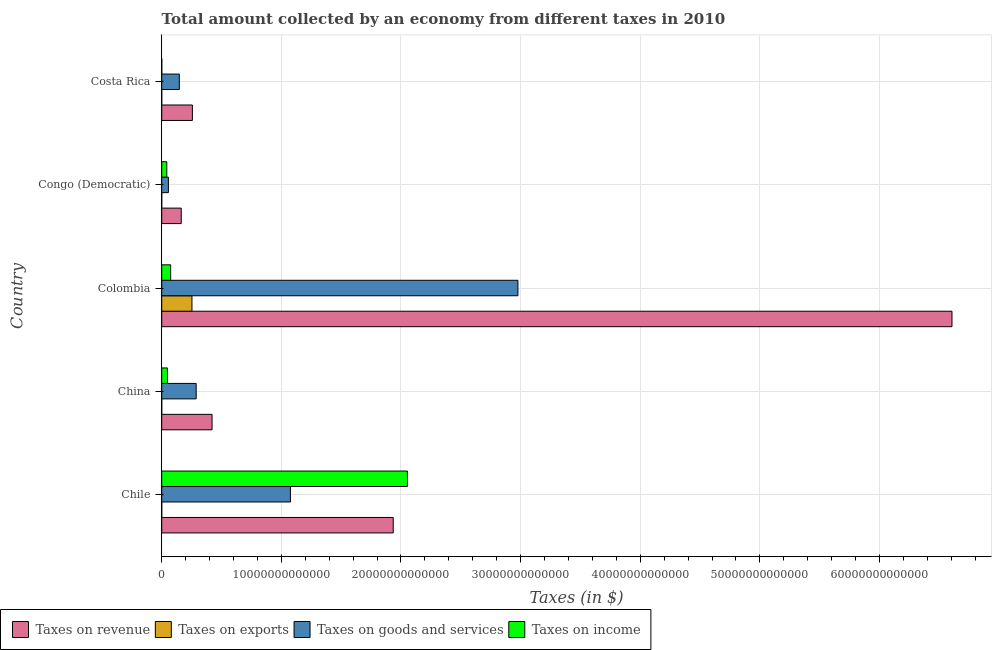How many different coloured bars are there?
Provide a short and direct response. 4. How many groups of bars are there?
Your answer should be very brief. 5. Are the number of bars per tick equal to the number of legend labels?
Ensure brevity in your answer.  Yes. How many bars are there on the 3rd tick from the bottom?
Your answer should be very brief. 4. What is the label of the 2nd group of bars from the top?
Your answer should be very brief. Congo (Democratic). In how many cases, is the number of bars for a given country not equal to the number of legend labels?
Your answer should be compact. 0. What is the amount collected as tax on exports in Congo (Democratic)?
Make the answer very short. 5.69e+06. Across all countries, what is the maximum amount collected as tax on revenue?
Give a very brief answer. 6.61e+13. Across all countries, what is the minimum amount collected as tax on exports?
Make the answer very short. 5.69e+06. In which country was the amount collected as tax on income maximum?
Your answer should be compact. Chile. In which country was the amount collected as tax on revenue minimum?
Ensure brevity in your answer.  Congo (Democratic). What is the total amount collected as tax on revenue in the graph?
Your response must be concise. 9.38e+13. What is the difference between the amount collected as tax on exports in Colombia and that in Congo (Democratic)?
Provide a short and direct response. 2.53e+12. What is the difference between the amount collected as tax on income in Colombia and the amount collected as tax on exports in Congo (Democratic)?
Provide a succinct answer. 7.48e+11. What is the average amount collected as tax on income per country?
Provide a succinct answer. 4.44e+12. What is the difference between the amount collected as tax on revenue and amount collected as tax on exports in Chile?
Give a very brief answer. 1.94e+13. In how many countries, is the amount collected as tax on income greater than 12000000000000 $?
Your response must be concise. 1. What is the ratio of the amount collected as tax on income in Chile to that in China?
Offer a terse response. 42.85. What is the difference between the highest and the second highest amount collected as tax on goods?
Offer a very short reply. 1.90e+13. What is the difference between the highest and the lowest amount collected as tax on income?
Make the answer very short. 2.05e+13. Is the sum of the amount collected as tax on exports in Chile and Colombia greater than the maximum amount collected as tax on goods across all countries?
Offer a very short reply. No. Is it the case that in every country, the sum of the amount collected as tax on income and amount collected as tax on revenue is greater than the sum of amount collected as tax on goods and amount collected as tax on exports?
Offer a very short reply. No. What does the 2nd bar from the top in Congo (Democratic) represents?
Provide a succinct answer. Taxes on goods and services. What does the 3rd bar from the bottom in Congo (Democratic) represents?
Your answer should be very brief. Taxes on goods and services. How many bars are there?
Ensure brevity in your answer.  20. How many countries are there in the graph?
Your answer should be very brief. 5. What is the difference between two consecutive major ticks on the X-axis?
Your answer should be very brief. 1.00e+13. Does the graph contain any zero values?
Give a very brief answer. No. Where does the legend appear in the graph?
Provide a succinct answer. Bottom left. What is the title of the graph?
Ensure brevity in your answer.  Total amount collected by an economy from different taxes in 2010. What is the label or title of the X-axis?
Give a very brief answer. Taxes (in $). What is the Taxes (in $) of Taxes on revenue in Chile?
Ensure brevity in your answer.  1.94e+13. What is the Taxes (in $) of Taxes on exports in Chile?
Your response must be concise. 9.15e+08. What is the Taxes (in $) in Taxes on goods and services in Chile?
Ensure brevity in your answer.  1.08e+13. What is the Taxes (in $) in Taxes on income in Chile?
Your answer should be compact. 2.05e+13. What is the Taxes (in $) of Taxes on revenue in China?
Make the answer very short. 4.21e+12. What is the Taxes (in $) in Taxes on exports in China?
Ensure brevity in your answer.  1.50e+08. What is the Taxes (in $) in Taxes on goods and services in China?
Keep it short and to the point. 2.88e+12. What is the Taxes (in $) in Taxes on income in China?
Your answer should be very brief. 4.79e+11. What is the Taxes (in $) in Taxes on revenue in Colombia?
Offer a very short reply. 6.61e+13. What is the Taxes (in $) of Taxes on exports in Colombia?
Ensure brevity in your answer.  2.53e+12. What is the Taxes (in $) in Taxes on goods and services in Colombia?
Your answer should be very brief. 2.98e+13. What is the Taxes (in $) in Taxes on income in Colombia?
Offer a terse response. 7.48e+11. What is the Taxes (in $) of Taxes on revenue in Congo (Democratic)?
Give a very brief answer. 1.63e+12. What is the Taxes (in $) in Taxes on exports in Congo (Democratic)?
Provide a succinct answer. 5.69e+06. What is the Taxes (in $) in Taxes on goods and services in Congo (Democratic)?
Ensure brevity in your answer.  5.59e+11. What is the Taxes (in $) in Taxes on income in Congo (Democratic)?
Your response must be concise. 4.24e+11. What is the Taxes (in $) of Taxes on revenue in Costa Rica?
Make the answer very short. 2.56e+12. What is the Taxes (in $) in Taxes on exports in Costa Rica?
Your answer should be very brief. 7.04e+07. What is the Taxes (in $) in Taxes on goods and services in Costa Rica?
Your answer should be compact. 1.47e+12. What is the Taxes (in $) in Taxes on income in Costa Rica?
Your response must be concise. 7.61e+09. Across all countries, what is the maximum Taxes (in $) in Taxes on revenue?
Your answer should be compact. 6.61e+13. Across all countries, what is the maximum Taxes (in $) in Taxes on exports?
Provide a short and direct response. 2.53e+12. Across all countries, what is the maximum Taxes (in $) in Taxes on goods and services?
Your answer should be compact. 2.98e+13. Across all countries, what is the maximum Taxes (in $) in Taxes on income?
Make the answer very short. 2.05e+13. Across all countries, what is the minimum Taxes (in $) in Taxes on revenue?
Offer a terse response. 1.63e+12. Across all countries, what is the minimum Taxes (in $) of Taxes on exports?
Provide a short and direct response. 5.69e+06. Across all countries, what is the minimum Taxes (in $) of Taxes on goods and services?
Offer a very short reply. 5.59e+11. Across all countries, what is the minimum Taxes (in $) in Taxes on income?
Offer a terse response. 7.61e+09. What is the total Taxes (in $) of Taxes on revenue in the graph?
Your response must be concise. 9.38e+13. What is the total Taxes (in $) in Taxes on exports in the graph?
Keep it short and to the point. 2.53e+12. What is the total Taxes (in $) in Taxes on goods and services in the graph?
Provide a short and direct response. 4.54e+13. What is the total Taxes (in $) of Taxes on income in the graph?
Your answer should be compact. 2.22e+13. What is the difference between the Taxes (in $) in Taxes on revenue in Chile and that in China?
Provide a succinct answer. 1.51e+13. What is the difference between the Taxes (in $) in Taxes on exports in Chile and that in China?
Your answer should be compact. 7.65e+08. What is the difference between the Taxes (in $) of Taxes on goods and services in Chile and that in China?
Your answer should be very brief. 7.88e+12. What is the difference between the Taxes (in $) of Taxes on income in Chile and that in China?
Your response must be concise. 2.01e+13. What is the difference between the Taxes (in $) in Taxes on revenue in Chile and that in Colombia?
Offer a very short reply. -4.67e+13. What is the difference between the Taxes (in $) in Taxes on exports in Chile and that in Colombia?
Provide a succinct answer. -2.53e+12. What is the difference between the Taxes (in $) in Taxes on goods and services in Chile and that in Colombia?
Provide a short and direct response. -1.90e+13. What is the difference between the Taxes (in $) of Taxes on income in Chile and that in Colombia?
Ensure brevity in your answer.  1.98e+13. What is the difference between the Taxes (in $) in Taxes on revenue in Chile and that in Congo (Democratic)?
Offer a terse response. 1.77e+13. What is the difference between the Taxes (in $) in Taxes on exports in Chile and that in Congo (Democratic)?
Provide a short and direct response. 9.10e+08. What is the difference between the Taxes (in $) in Taxes on goods and services in Chile and that in Congo (Democratic)?
Your answer should be very brief. 1.02e+13. What is the difference between the Taxes (in $) in Taxes on income in Chile and that in Congo (Democratic)?
Give a very brief answer. 2.01e+13. What is the difference between the Taxes (in $) of Taxes on revenue in Chile and that in Costa Rica?
Make the answer very short. 1.68e+13. What is the difference between the Taxes (in $) of Taxes on exports in Chile and that in Costa Rica?
Your response must be concise. 8.45e+08. What is the difference between the Taxes (in $) of Taxes on goods and services in Chile and that in Costa Rica?
Your answer should be compact. 9.29e+12. What is the difference between the Taxes (in $) of Taxes on income in Chile and that in Costa Rica?
Offer a terse response. 2.05e+13. What is the difference between the Taxes (in $) in Taxes on revenue in China and that in Colombia?
Keep it short and to the point. -6.19e+13. What is the difference between the Taxes (in $) in Taxes on exports in China and that in Colombia?
Provide a succinct answer. -2.53e+12. What is the difference between the Taxes (in $) in Taxes on goods and services in China and that in Colombia?
Provide a short and direct response. -2.69e+13. What is the difference between the Taxes (in $) of Taxes on income in China and that in Colombia?
Your answer should be compact. -2.69e+11. What is the difference between the Taxes (in $) of Taxes on revenue in China and that in Congo (Democratic)?
Ensure brevity in your answer.  2.58e+12. What is the difference between the Taxes (in $) of Taxes on exports in China and that in Congo (Democratic)?
Offer a terse response. 1.44e+08. What is the difference between the Taxes (in $) of Taxes on goods and services in China and that in Congo (Democratic)?
Provide a short and direct response. 2.32e+12. What is the difference between the Taxes (in $) of Taxes on income in China and that in Congo (Democratic)?
Your answer should be very brief. 5.58e+1. What is the difference between the Taxes (in $) in Taxes on revenue in China and that in Costa Rica?
Your answer should be very brief. 1.64e+12. What is the difference between the Taxes (in $) in Taxes on exports in China and that in Costa Rica?
Give a very brief answer. 7.96e+07. What is the difference between the Taxes (in $) in Taxes on goods and services in China and that in Costa Rica?
Your answer should be very brief. 1.41e+12. What is the difference between the Taxes (in $) in Taxes on income in China and that in Costa Rica?
Keep it short and to the point. 4.72e+11. What is the difference between the Taxes (in $) of Taxes on revenue in Colombia and that in Congo (Democratic)?
Keep it short and to the point. 6.44e+13. What is the difference between the Taxes (in $) in Taxes on exports in Colombia and that in Congo (Democratic)?
Your answer should be compact. 2.53e+12. What is the difference between the Taxes (in $) in Taxes on goods and services in Colombia and that in Congo (Democratic)?
Ensure brevity in your answer.  2.92e+13. What is the difference between the Taxes (in $) of Taxes on income in Colombia and that in Congo (Democratic)?
Your answer should be very brief. 3.25e+11. What is the difference between the Taxes (in $) of Taxes on revenue in Colombia and that in Costa Rica?
Keep it short and to the point. 6.35e+13. What is the difference between the Taxes (in $) in Taxes on exports in Colombia and that in Costa Rica?
Your answer should be compact. 2.53e+12. What is the difference between the Taxes (in $) in Taxes on goods and services in Colombia and that in Costa Rica?
Ensure brevity in your answer.  2.83e+13. What is the difference between the Taxes (in $) of Taxes on income in Colombia and that in Costa Rica?
Offer a terse response. 7.40e+11. What is the difference between the Taxes (in $) of Taxes on revenue in Congo (Democratic) and that in Costa Rica?
Your answer should be compact. -9.33e+11. What is the difference between the Taxes (in $) in Taxes on exports in Congo (Democratic) and that in Costa Rica?
Your response must be concise. -6.47e+07. What is the difference between the Taxes (in $) of Taxes on goods and services in Congo (Democratic) and that in Costa Rica?
Provide a succinct answer. -9.12e+11. What is the difference between the Taxes (in $) of Taxes on income in Congo (Democratic) and that in Costa Rica?
Keep it short and to the point. 4.16e+11. What is the difference between the Taxes (in $) in Taxes on revenue in Chile and the Taxes (in $) in Taxes on exports in China?
Provide a short and direct response. 1.94e+13. What is the difference between the Taxes (in $) of Taxes on revenue in Chile and the Taxes (in $) of Taxes on goods and services in China?
Your response must be concise. 1.65e+13. What is the difference between the Taxes (in $) in Taxes on revenue in Chile and the Taxes (in $) in Taxes on income in China?
Make the answer very short. 1.89e+13. What is the difference between the Taxes (in $) of Taxes on exports in Chile and the Taxes (in $) of Taxes on goods and services in China?
Your response must be concise. -2.88e+12. What is the difference between the Taxes (in $) in Taxes on exports in Chile and the Taxes (in $) in Taxes on income in China?
Give a very brief answer. -4.78e+11. What is the difference between the Taxes (in $) of Taxes on goods and services in Chile and the Taxes (in $) of Taxes on income in China?
Offer a very short reply. 1.03e+13. What is the difference between the Taxes (in $) of Taxes on revenue in Chile and the Taxes (in $) of Taxes on exports in Colombia?
Provide a short and direct response. 1.68e+13. What is the difference between the Taxes (in $) in Taxes on revenue in Chile and the Taxes (in $) in Taxes on goods and services in Colombia?
Your answer should be compact. -1.04e+13. What is the difference between the Taxes (in $) in Taxes on revenue in Chile and the Taxes (in $) in Taxes on income in Colombia?
Provide a succinct answer. 1.86e+13. What is the difference between the Taxes (in $) in Taxes on exports in Chile and the Taxes (in $) in Taxes on goods and services in Colombia?
Offer a terse response. -2.98e+13. What is the difference between the Taxes (in $) of Taxes on exports in Chile and the Taxes (in $) of Taxes on income in Colombia?
Give a very brief answer. -7.47e+11. What is the difference between the Taxes (in $) of Taxes on goods and services in Chile and the Taxes (in $) of Taxes on income in Colombia?
Your answer should be compact. 1.00e+13. What is the difference between the Taxes (in $) in Taxes on revenue in Chile and the Taxes (in $) in Taxes on exports in Congo (Democratic)?
Provide a succinct answer. 1.94e+13. What is the difference between the Taxes (in $) in Taxes on revenue in Chile and the Taxes (in $) in Taxes on goods and services in Congo (Democratic)?
Your response must be concise. 1.88e+13. What is the difference between the Taxes (in $) in Taxes on revenue in Chile and the Taxes (in $) in Taxes on income in Congo (Democratic)?
Your answer should be very brief. 1.89e+13. What is the difference between the Taxes (in $) of Taxes on exports in Chile and the Taxes (in $) of Taxes on goods and services in Congo (Democratic)?
Provide a succinct answer. -5.58e+11. What is the difference between the Taxes (in $) in Taxes on exports in Chile and the Taxes (in $) in Taxes on income in Congo (Democratic)?
Provide a short and direct response. -4.23e+11. What is the difference between the Taxes (in $) in Taxes on goods and services in Chile and the Taxes (in $) in Taxes on income in Congo (Democratic)?
Ensure brevity in your answer.  1.03e+13. What is the difference between the Taxes (in $) of Taxes on revenue in Chile and the Taxes (in $) of Taxes on exports in Costa Rica?
Provide a short and direct response. 1.94e+13. What is the difference between the Taxes (in $) in Taxes on revenue in Chile and the Taxes (in $) in Taxes on goods and services in Costa Rica?
Provide a short and direct response. 1.79e+13. What is the difference between the Taxes (in $) of Taxes on revenue in Chile and the Taxes (in $) of Taxes on income in Costa Rica?
Your response must be concise. 1.93e+13. What is the difference between the Taxes (in $) of Taxes on exports in Chile and the Taxes (in $) of Taxes on goods and services in Costa Rica?
Your answer should be very brief. -1.47e+12. What is the difference between the Taxes (in $) in Taxes on exports in Chile and the Taxes (in $) in Taxes on income in Costa Rica?
Give a very brief answer. -6.69e+09. What is the difference between the Taxes (in $) of Taxes on goods and services in Chile and the Taxes (in $) of Taxes on income in Costa Rica?
Ensure brevity in your answer.  1.08e+13. What is the difference between the Taxes (in $) in Taxes on revenue in China and the Taxes (in $) in Taxes on exports in Colombia?
Provide a short and direct response. 1.68e+12. What is the difference between the Taxes (in $) in Taxes on revenue in China and the Taxes (in $) in Taxes on goods and services in Colombia?
Your answer should be compact. -2.56e+13. What is the difference between the Taxes (in $) in Taxes on revenue in China and the Taxes (in $) in Taxes on income in Colombia?
Keep it short and to the point. 3.46e+12. What is the difference between the Taxes (in $) of Taxes on exports in China and the Taxes (in $) of Taxes on goods and services in Colombia?
Keep it short and to the point. -2.98e+13. What is the difference between the Taxes (in $) in Taxes on exports in China and the Taxes (in $) in Taxes on income in Colombia?
Make the answer very short. -7.48e+11. What is the difference between the Taxes (in $) of Taxes on goods and services in China and the Taxes (in $) of Taxes on income in Colombia?
Keep it short and to the point. 2.13e+12. What is the difference between the Taxes (in $) of Taxes on revenue in China and the Taxes (in $) of Taxes on exports in Congo (Democratic)?
Provide a short and direct response. 4.21e+12. What is the difference between the Taxes (in $) of Taxes on revenue in China and the Taxes (in $) of Taxes on goods and services in Congo (Democratic)?
Provide a succinct answer. 3.65e+12. What is the difference between the Taxes (in $) of Taxes on revenue in China and the Taxes (in $) of Taxes on income in Congo (Democratic)?
Give a very brief answer. 3.79e+12. What is the difference between the Taxes (in $) of Taxes on exports in China and the Taxes (in $) of Taxes on goods and services in Congo (Democratic)?
Ensure brevity in your answer.  -5.59e+11. What is the difference between the Taxes (in $) in Taxes on exports in China and the Taxes (in $) in Taxes on income in Congo (Democratic)?
Ensure brevity in your answer.  -4.23e+11. What is the difference between the Taxes (in $) in Taxes on goods and services in China and the Taxes (in $) in Taxes on income in Congo (Democratic)?
Offer a very short reply. 2.46e+12. What is the difference between the Taxes (in $) of Taxes on revenue in China and the Taxes (in $) of Taxes on exports in Costa Rica?
Offer a very short reply. 4.21e+12. What is the difference between the Taxes (in $) of Taxes on revenue in China and the Taxes (in $) of Taxes on goods and services in Costa Rica?
Ensure brevity in your answer.  2.74e+12. What is the difference between the Taxes (in $) in Taxes on revenue in China and the Taxes (in $) in Taxes on income in Costa Rica?
Provide a succinct answer. 4.20e+12. What is the difference between the Taxes (in $) in Taxes on exports in China and the Taxes (in $) in Taxes on goods and services in Costa Rica?
Your response must be concise. -1.47e+12. What is the difference between the Taxes (in $) of Taxes on exports in China and the Taxes (in $) of Taxes on income in Costa Rica?
Make the answer very short. -7.46e+09. What is the difference between the Taxes (in $) of Taxes on goods and services in China and the Taxes (in $) of Taxes on income in Costa Rica?
Make the answer very short. 2.87e+12. What is the difference between the Taxes (in $) of Taxes on revenue in Colombia and the Taxes (in $) of Taxes on exports in Congo (Democratic)?
Offer a terse response. 6.61e+13. What is the difference between the Taxes (in $) of Taxes on revenue in Colombia and the Taxes (in $) of Taxes on goods and services in Congo (Democratic)?
Your answer should be very brief. 6.55e+13. What is the difference between the Taxes (in $) in Taxes on revenue in Colombia and the Taxes (in $) in Taxes on income in Congo (Democratic)?
Provide a succinct answer. 6.56e+13. What is the difference between the Taxes (in $) of Taxes on exports in Colombia and the Taxes (in $) of Taxes on goods and services in Congo (Democratic)?
Your response must be concise. 1.97e+12. What is the difference between the Taxes (in $) in Taxes on exports in Colombia and the Taxes (in $) in Taxes on income in Congo (Democratic)?
Offer a very short reply. 2.10e+12. What is the difference between the Taxes (in $) of Taxes on goods and services in Colombia and the Taxes (in $) of Taxes on income in Congo (Democratic)?
Provide a short and direct response. 2.94e+13. What is the difference between the Taxes (in $) in Taxes on revenue in Colombia and the Taxes (in $) in Taxes on exports in Costa Rica?
Offer a terse response. 6.61e+13. What is the difference between the Taxes (in $) in Taxes on revenue in Colombia and the Taxes (in $) in Taxes on goods and services in Costa Rica?
Give a very brief answer. 6.46e+13. What is the difference between the Taxes (in $) of Taxes on revenue in Colombia and the Taxes (in $) of Taxes on income in Costa Rica?
Your response must be concise. 6.61e+13. What is the difference between the Taxes (in $) of Taxes on exports in Colombia and the Taxes (in $) of Taxes on goods and services in Costa Rica?
Your answer should be very brief. 1.06e+12. What is the difference between the Taxes (in $) in Taxes on exports in Colombia and the Taxes (in $) in Taxes on income in Costa Rica?
Your answer should be compact. 2.52e+12. What is the difference between the Taxes (in $) of Taxes on goods and services in Colombia and the Taxes (in $) of Taxes on income in Costa Rica?
Give a very brief answer. 2.98e+13. What is the difference between the Taxes (in $) in Taxes on revenue in Congo (Democratic) and the Taxes (in $) in Taxes on exports in Costa Rica?
Offer a terse response. 1.63e+12. What is the difference between the Taxes (in $) in Taxes on revenue in Congo (Democratic) and the Taxes (in $) in Taxes on goods and services in Costa Rica?
Keep it short and to the point. 1.60e+11. What is the difference between the Taxes (in $) of Taxes on revenue in Congo (Democratic) and the Taxes (in $) of Taxes on income in Costa Rica?
Keep it short and to the point. 1.62e+12. What is the difference between the Taxes (in $) in Taxes on exports in Congo (Democratic) and the Taxes (in $) in Taxes on goods and services in Costa Rica?
Provide a succinct answer. -1.47e+12. What is the difference between the Taxes (in $) in Taxes on exports in Congo (Democratic) and the Taxes (in $) in Taxes on income in Costa Rica?
Your answer should be very brief. -7.60e+09. What is the difference between the Taxes (in $) of Taxes on goods and services in Congo (Democratic) and the Taxes (in $) of Taxes on income in Costa Rica?
Provide a succinct answer. 5.52e+11. What is the average Taxes (in $) of Taxes on revenue per country?
Your response must be concise. 1.88e+13. What is the average Taxes (in $) in Taxes on exports per country?
Ensure brevity in your answer.  5.06e+11. What is the average Taxes (in $) in Taxes on goods and services per country?
Give a very brief answer. 9.09e+12. What is the average Taxes (in $) in Taxes on income per country?
Ensure brevity in your answer.  4.44e+12. What is the difference between the Taxes (in $) in Taxes on revenue and Taxes (in $) in Taxes on exports in Chile?
Ensure brevity in your answer.  1.94e+13. What is the difference between the Taxes (in $) of Taxes on revenue and Taxes (in $) of Taxes on goods and services in Chile?
Make the answer very short. 8.59e+12. What is the difference between the Taxes (in $) of Taxes on revenue and Taxes (in $) of Taxes on income in Chile?
Provide a short and direct response. -1.19e+12. What is the difference between the Taxes (in $) in Taxes on exports and Taxes (in $) in Taxes on goods and services in Chile?
Give a very brief answer. -1.08e+13. What is the difference between the Taxes (in $) of Taxes on exports and Taxes (in $) of Taxes on income in Chile?
Your answer should be compact. -2.05e+13. What is the difference between the Taxes (in $) of Taxes on goods and services and Taxes (in $) of Taxes on income in Chile?
Your answer should be very brief. -9.78e+12. What is the difference between the Taxes (in $) in Taxes on revenue and Taxes (in $) in Taxes on exports in China?
Your answer should be very brief. 4.21e+12. What is the difference between the Taxes (in $) in Taxes on revenue and Taxes (in $) in Taxes on goods and services in China?
Your answer should be very brief. 1.33e+12. What is the difference between the Taxes (in $) of Taxes on revenue and Taxes (in $) of Taxes on income in China?
Offer a very short reply. 3.73e+12. What is the difference between the Taxes (in $) of Taxes on exports and Taxes (in $) of Taxes on goods and services in China?
Offer a terse response. -2.88e+12. What is the difference between the Taxes (in $) in Taxes on exports and Taxes (in $) in Taxes on income in China?
Give a very brief answer. -4.79e+11. What is the difference between the Taxes (in $) in Taxes on goods and services and Taxes (in $) in Taxes on income in China?
Ensure brevity in your answer.  2.40e+12. What is the difference between the Taxes (in $) in Taxes on revenue and Taxes (in $) in Taxes on exports in Colombia?
Your response must be concise. 6.35e+13. What is the difference between the Taxes (in $) of Taxes on revenue and Taxes (in $) of Taxes on goods and services in Colombia?
Provide a short and direct response. 3.63e+13. What is the difference between the Taxes (in $) of Taxes on revenue and Taxes (in $) of Taxes on income in Colombia?
Ensure brevity in your answer.  6.53e+13. What is the difference between the Taxes (in $) of Taxes on exports and Taxes (in $) of Taxes on goods and services in Colombia?
Make the answer very short. -2.72e+13. What is the difference between the Taxes (in $) of Taxes on exports and Taxes (in $) of Taxes on income in Colombia?
Give a very brief answer. 1.78e+12. What is the difference between the Taxes (in $) of Taxes on goods and services and Taxes (in $) of Taxes on income in Colombia?
Keep it short and to the point. 2.90e+13. What is the difference between the Taxes (in $) of Taxes on revenue and Taxes (in $) of Taxes on exports in Congo (Democratic)?
Your answer should be very brief. 1.63e+12. What is the difference between the Taxes (in $) of Taxes on revenue and Taxes (in $) of Taxes on goods and services in Congo (Democratic)?
Make the answer very short. 1.07e+12. What is the difference between the Taxes (in $) in Taxes on revenue and Taxes (in $) in Taxes on income in Congo (Democratic)?
Your answer should be very brief. 1.21e+12. What is the difference between the Taxes (in $) of Taxes on exports and Taxes (in $) of Taxes on goods and services in Congo (Democratic)?
Give a very brief answer. -5.59e+11. What is the difference between the Taxes (in $) of Taxes on exports and Taxes (in $) of Taxes on income in Congo (Democratic)?
Offer a terse response. -4.23e+11. What is the difference between the Taxes (in $) of Taxes on goods and services and Taxes (in $) of Taxes on income in Congo (Democratic)?
Provide a short and direct response. 1.36e+11. What is the difference between the Taxes (in $) of Taxes on revenue and Taxes (in $) of Taxes on exports in Costa Rica?
Keep it short and to the point. 2.56e+12. What is the difference between the Taxes (in $) in Taxes on revenue and Taxes (in $) in Taxes on goods and services in Costa Rica?
Your answer should be very brief. 1.09e+12. What is the difference between the Taxes (in $) in Taxes on revenue and Taxes (in $) in Taxes on income in Costa Rica?
Provide a succinct answer. 2.56e+12. What is the difference between the Taxes (in $) of Taxes on exports and Taxes (in $) of Taxes on goods and services in Costa Rica?
Your response must be concise. -1.47e+12. What is the difference between the Taxes (in $) in Taxes on exports and Taxes (in $) in Taxes on income in Costa Rica?
Give a very brief answer. -7.54e+09. What is the difference between the Taxes (in $) in Taxes on goods and services and Taxes (in $) in Taxes on income in Costa Rica?
Offer a very short reply. 1.46e+12. What is the ratio of the Taxes (in $) of Taxes on revenue in Chile to that in China?
Ensure brevity in your answer.  4.6. What is the ratio of the Taxes (in $) in Taxes on exports in Chile to that in China?
Keep it short and to the point. 6.1. What is the ratio of the Taxes (in $) of Taxes on goods and services in Chile to that in China?
Make the answer very short. 3.74. What is the ratio of the Taxes (in $) of Taxes on income in Chile to that in China?
Your response must be concise. 42.85. What is the ratio of the Taxes (in $) of Taxes on revenue in Chile to that in Colombia?
Your answer should be very brief. 0.29. What is the ratio of the Taxes (in $) of Taxes on exports in Chile to that in Colombia?
Your response must be concise. 0. What is the ratio of the Taxes (in $) in Taxes on goods and services in Chile to that in Colombia?
Offer a very short reply. 0.36. What is the ratio of the Taxes (in $) of Taxes on income in Chile to that in Colombia?
Ensure brevity in your answer.  27.46. What is the ratio of the Taxes (in $) in Taxes on revenue in Chile to that in Congo (Democratic)?
Your answer should be compact. 11.86. What is the ratio of the Taxes (in $) of Taxes on exports in Chile to that in Congo (Democratic)?
Keep it short and to the point. 160.8. What is the ratio of the Taxes (in $) in Taxes on goods and services in Chile to that in Congo (Democratic)?
Offer a very short reply. 19.24. What is the ratio of the Taxes (in $) in Taxes on income in Chile to that in Congo (Democratic)?
Ensure brevity in your answer.  48.5. What is the ratio of the Taxes (in $) in Taxes on revenue in Chile to that in Costa Rica?
Provide a succinct answer. 7.55. What is the ratio of the Taxes (in $) in Taxes on exports in Chile to that in Costa Rica?
Make the answer very short. 13.01. What is the ratio of the Taxes (in $) of Taxes on goods and services in Chile to that in Costa Rica?
Ensure brevity in your answer.  7.31. What is the ratio of the Taxes (in $) of Taxes on income in Chile to that in Costa Rica?
Offer a very short reply. 2699.44. What is the ratio of the Taxes (in $) in Taxes on revenue in China to that in Colombia?
Offer a very short reply. 0.06. What is the ratio of the Taxes (in $) in Taxes on exports in China to that in Colombia?
Your answer should be very brief. 0. What is the ratio of the Taxes (in $) of Taxes on goods and services in China to that in Colombia?
Offer a terse response. 0.1. What is the ratio of the Taxes (in $) in Taxes on income in China to that in Colombia?
Offer a very short reply. 0.64. What is the ratio of the Taxes (in $) in Taxes on revenue in China to that in Congo (Democratic)?
Ensure brevity in your answer.  2.58. What is the ratio of the Taxes (in $) of Taxes on exports in China to that in Congo (Democratic)?
Provide a short and direct response. 26.35. What is the ratio of the Taxes (in $) of Taxes on goods and services in China to that in Congo (Democratic)?
Your response must be concise. 5.15. What is the ratio of the Taxes (in $) of Taxes on income in China to that in Congo (Democratic)?
Provide a short and direct response. 1.13. What is the ratio of the Taxes (in $) in Taxes on revenue in China to that in Costa Rica?
Your answer should be very brief. 1.64. What is the ratio of the Taxes (in $) of Taxes on exports in China to that in Costa Rica?
Provide a succinct answer. 2.13. What is the ratio of the Taxes (in $) of Taxes on goods and services in China to that in Costa Rica?
Provide a short and direct response. 1.96. What is the ratio of the Taxes (in $) in Taxes on income in China to that in Costa Rica?
Give a very brief answer. 62.99. What is the ratio of the Taxes (in $) of Taxes on revenue in Colombia to that in Congo (Democratic)?
Give a very brief answer. 40.49. What is the ratio of the Taxes (in $) in Taxes on exports in Colombia to that in Congo (Democratic)?
Provide a succinct answer. 4.44e+05. What is the ratio of the Taxes (in $) of Taxes on goods and services in Colombia to that in Congo (Democratic)?
Offer a terse response. 53.24. What is the ratio of the Taxes (in $) in Taxes on income in Colombia to that in Congo (Democratic)?
Ensure brevity in your answer.  1.77. What is the ratio of the Taxes (in $) in Taxes on revenue in Colombia to that in Costa Rica?
Offer a very short reply. 25.76. What is the ratio of the Taxes (in $) of Taxes on exports in Colombia to that in Costa Rica?
Make the answer very short. 3.59e+04. What is the ratio of the Taxes (in $) of Taxes on goods and services in Colombia to that in Costa Rica?
Give a very brief answer. 20.24. What is the ratio of the Taxes (in $) in Taxes on income in Colombia to that in Costa Rica?
Ensure brevity in your answer.  98.32. What is the ratio of the Taxes (in $) of Taxes on revenue in Congo (Democratic) to that in Costa Rica?
Keep it short and to the point. 0.64. What is the ratio of the Taxes (in $) of Taxes on exports in Congo (Democratic) to that in Costa Rica?
Your answer should be very brief. 0.08. What is the ratio of the Taxes (in $) of Taxes on goods and services in Congo (Democratic) to that in Costa Rica?
Make the answer very short. 0.38. What is the ratio of the Taxes (in $) of Taxes on income in Congo (Democratic) to that in Costa Rica?
Make the answer very short. 55.66. What is the difference between the highest and the second highest Taxes (in $) in Taxes on revenue?
Make the answer very short. 4.67e+13. What is the difference between the highest and the second highest Taxes (in $) in Taxes on exports?
Give a very brief answer. 2.53e+12. What is the difference between the highest and the second highest Taxes (in $) in Taxes on goods and services?
Your answer should be compact. 1.90e+13. What is the difference between the highest and the second highest Taxes (in $) in Taxes on income?
Your answer should be compact. 1.98e+13. What is the difference between the highest and the lowest Taxes (in $) in Taxes on revenue?
Your response must be concise. 6.44e+13. What is the difference between the highest and the lowest Taxes (in $) of Taxes on exports?
Provide a short and direct response. 2.53e+12. What is the difference between the highest and the lowest Taxes (in $) of Taxes on goods and services?
Your response must be concise. 2.92e+13. What is the difference between the highest and the lowest Taxes (in $) in Taxes on income?
Your answer should be compact. 2.05e+13. 